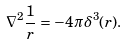<formula> <loc_0><loc_0><loc_500><loc_500>\nabla ^ { 2 } \frac { 1 } { r } = - 4 \pi \delta ^ { 3 } ( r ) .</formula> 